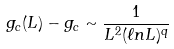<formula> <loc_0><loc_0><loc_500><loc_500>g _ { c } ( L ) - g _ { c } \sim \frac { 1 } { L ^ { 2 } ( { \ell } n L ) ^ { q } }</formula> 